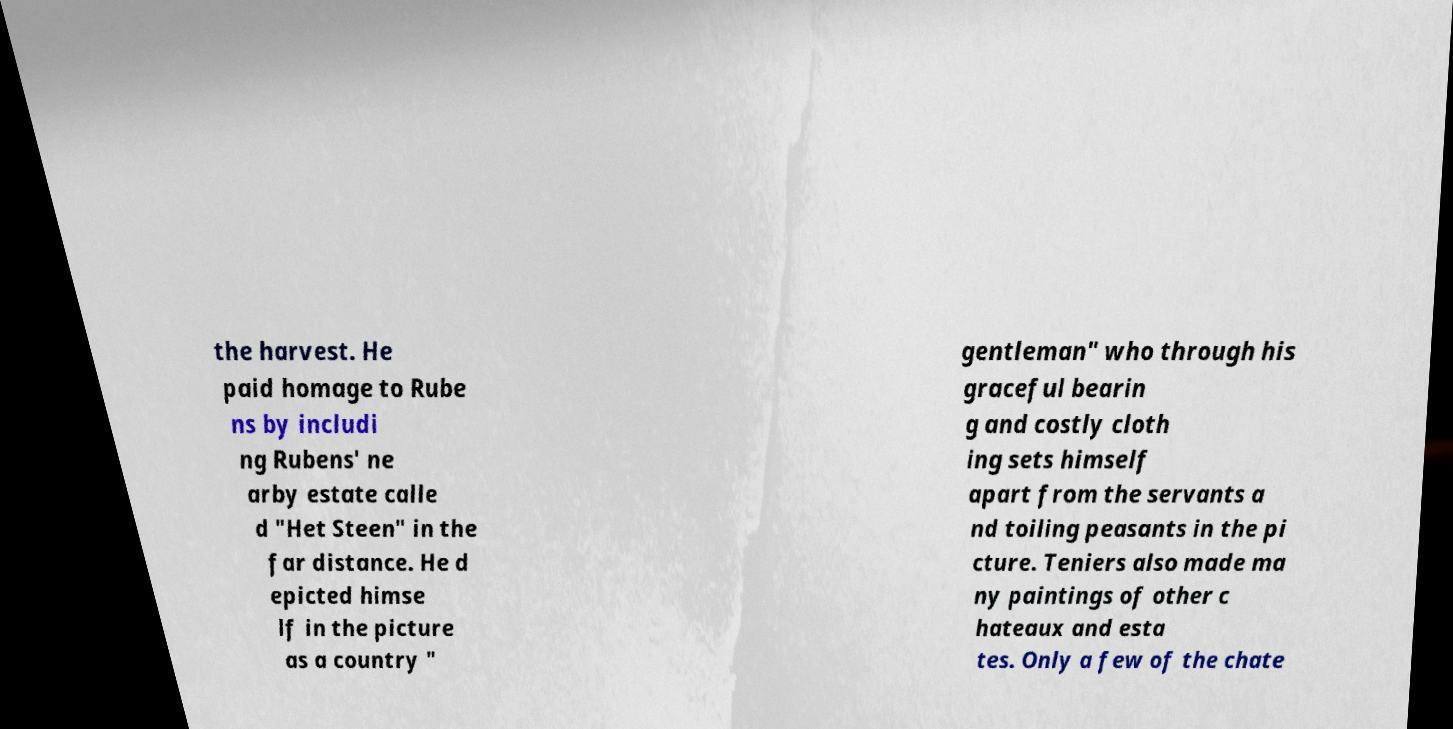Could you extract and type out the text from this image? the harvest. He paid homage to Rube ns by includi ng Rubens' ne arby estate calle d "Het Steen" in the far distance. He d epicted himse lf in the picture as a country " gentleman" who through his graceful bearin g and costly cloth ing sets himself apart from the servants a nd toiling peasants in the pi cture. Teniers also made ma ny paintings of other c hateaux and esta tes. Only a few of the chate 